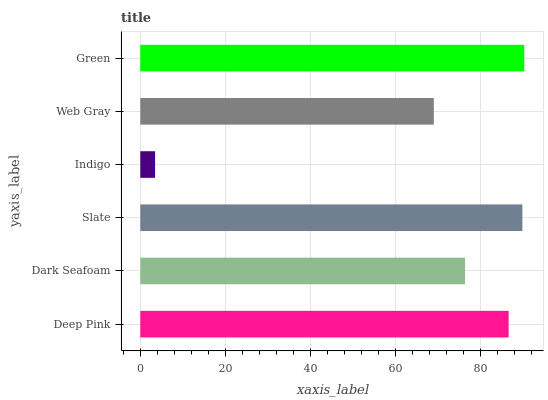Is Indigo the minimum?
Answer yes or no. Yes. Is Green the maximum?
Answer yes or no. Yes. Is Dark Seafoam the minimum?
Answer yes or no. No. Is Dark Seafoam the maximum?
Answer yes or no. No. Is Deep Pink greater than Dark Seafoam?
Answer yes or no. Yes. Is Dark Seafoam less than Deep Pink?
Answer yes or no. Yes. Is Dark Seafoam greater than Deep Pink?
Answer yes or no. No. Is Deep Pink less than Dark Seafoam?
Answer yes or no. No. Is Deep Pink the high median?
Answer yes or no. Yes. Is Dark Seafoam the low median?
Answer yes or no. Yes. Is Dark Seafoam the high median?
Answer yes or no. No. Is Deep Pink the low median?
Answer yes or no. No. 